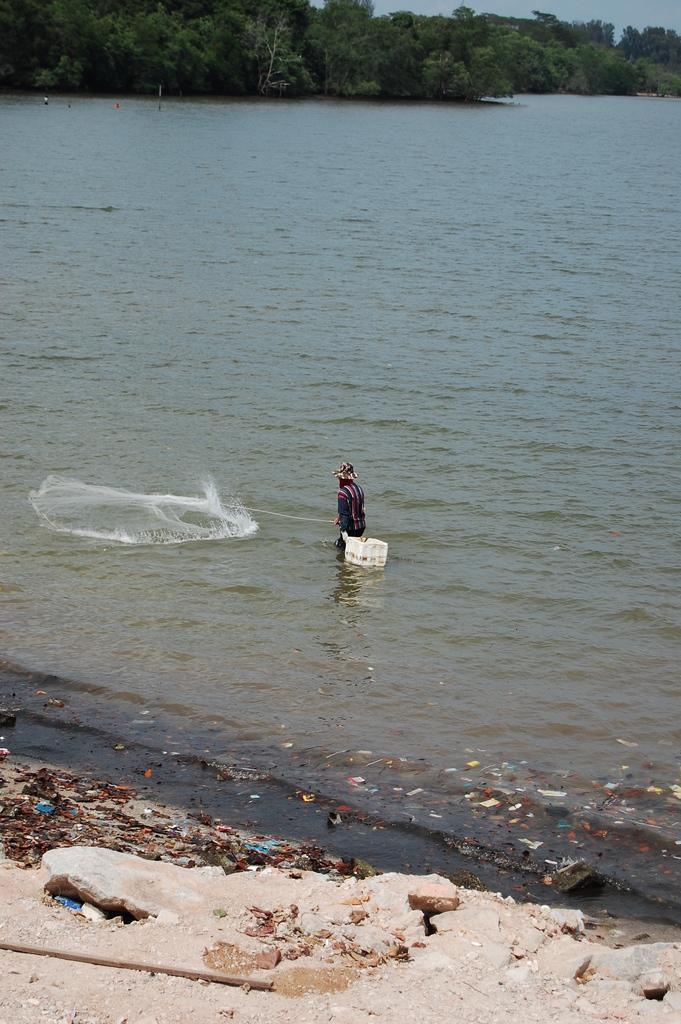Can you describe this image briefly? There is one man in the water and holding a net as we can see in the middle of this image, and there are trees at the top of this image. 